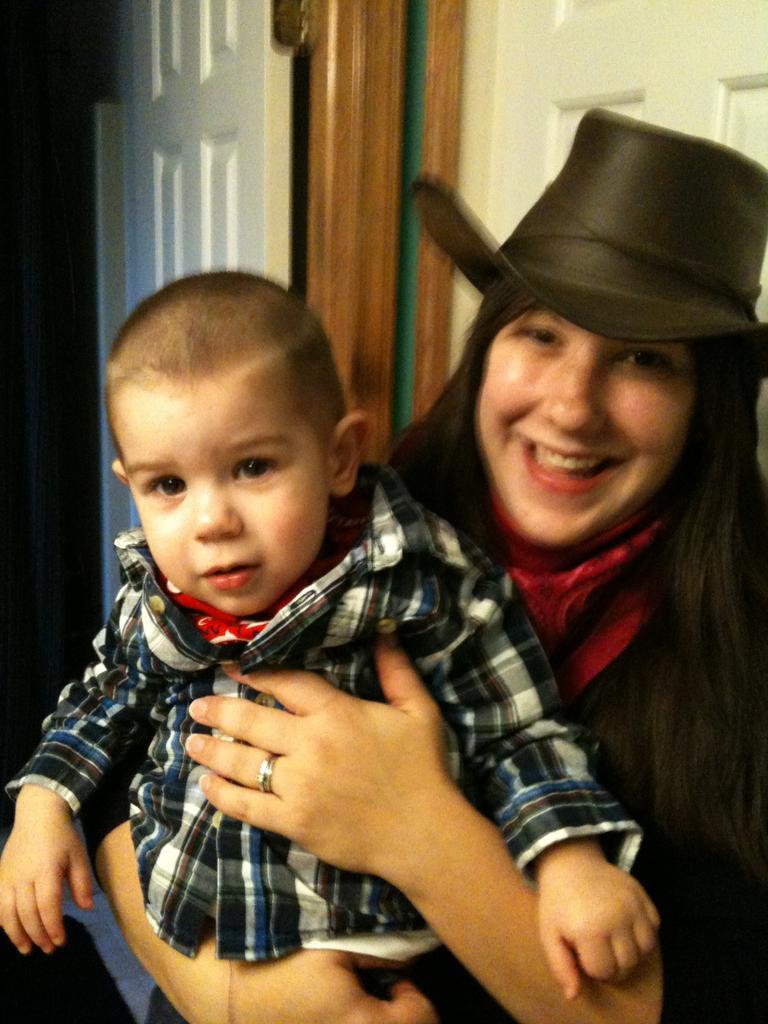Can you describe this image briefly? In this picture we can see a woman wore a hat and holding a child with her hands and smiling and in the background we can see doors. 